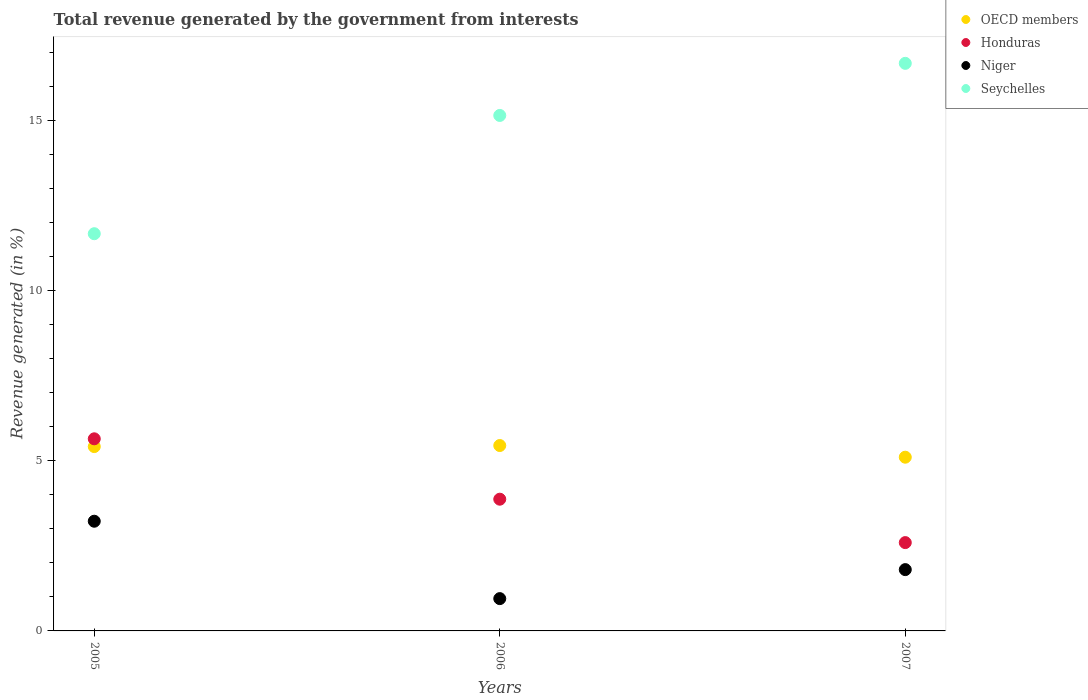How many different coloured dotlines are there?
Provide a succinct answer. 4. What is the total revenue generated in Honduras in 2007?
Offer a terse response. 2.6. Across all years, what is the maximum total revenue generated in Seychelles?
Make the answer very short. 16.68. Across all years, what is the minimum total revenue generated in Honduras?
Provide a succinct answer. 2.6. In which year was the total revenue generated in Niger maximum?
Your answer should be very brief. 2005. What is the total total revenue generated in OECD members in the graph?
Your response must be concise. 15.97. What is the difference between the total revenue generated in Honduras in 2005 and that in 2006?
Your answer should be compact. 1.77. What is the difference between the total revenue generated in OECD members in 2006 and the total revenue generated in Honduras in 2007?
Your response must be concise. 2.85. What is the average total revenue generated in Seychelles per year?
Offer a terse response. 14.5. In the year 2006, what is the difference between the total revenue generated in Honduras and total revenue generated in Niger?
Give a very brief answer. 2.92. What is the ratio of the total revenue generated in Niger in 2006 to that in 2007?
Provide a succinct answer. 0.53. Is the difference between the total revenue generated in Honduras in 2005 and 2007 greater than the difference between the total revenue generated in Niger in 2005 and 2007?
Provide a short and direct response. Yes. What is the difference between the highest and the second highest total revenue generated in OECD members?
Give a very brief answer. 0.03. What is the difference between the highest and the lowest total revenue generated in Seychelles?
Offer a terse response. 5.01. Is it the case that in every year, the sum of the total revenue generated in OECD members and total revenue generated in Seychelles  is greater than the sum of total revenue generated in Honduras and total revenue generated in Niger?
Your response must be concise. Yes. Is it the case that in every year, the sum of the total revenue generated in Niger and total revenue generated in Honduras  is greater than the total revenue generated in Seychelles?
Ensure brevity in your answer.  No. Is the total revenue generated in Honduras strictly greater than the total revenue generated in Seychelles over the years?
Offer a very short reply. No. How many years are there in the graph?
Your answer should be compact. 3. Are the values on the major ticks of Y-axis written in scientific E-notation?
Provide a succinct answer. No. Does the graph contain any zero values?
Provide a succinct answer. No. Where does the legend appear in the graph?
Offer a terse response. Top right. How many legend labels are there?
Offer a very short reply. 4. How are the legend labels stacked?
Your answer should be compact. Vertical. What is the title of the graph?
Your answer should be very brief. Total revenue generated by the government from interests. What is the label or title of the X-axis?
Offer a terse response. Years. What is the label or title of the Y-axis?
Offer a terse response. Revenue generated (in %). What is the Revenue generated (in %) in OECD members in 2005?
Give a very brief answer. 5.42. What is the Revenue generated (in %) of Honduras in 2005?
Provide a short and direct response. 5.64. What is the Revenue generated (in %) of Niger in 2005?
Your response must be concise. 3.22. What is the Revenue generated (in %) of Seychelles in 2005?
Your answer should be compact. 11.67. What is the Revenue generated (in %) in OECD members in 2006?
Your answer should be compact. 5.45. What is the Revenue generated (in %) in Honduras in 2006?
Give a very brief answer. 3.87. What is the Revenue generated (in %) in Niger in 2006?
Offer a terse response. 0.95. What is the Revenue generated (in %) in Seychelles in 2006?
Make the answer very short. 15.15. What is the Revenue generated (in %) of OECD members in 2007?
Offer a terse response. 5.1. What is the Revenue generated (in %) of Honduras in 2007?
Your answer should be very brief. 2.6. What is the Revenue generated (in %) of Niger in 2007?
Provide a short and direct response. 1.8. What is the Revenue generated (in %) in Seychelles in 2007?
Make the answer very short. 16.68. Across all years, what is the maximum Revenue generated (in %) in OECD members?
Make the answer very short. 5.45. Across all years, what is the maximum Revenue generated (in %) of Honduras?
Your response must be concise. 5.64. Across all years, what is the maximum Revenue generated (in %) of Niger?
Offer a very short reply. 3.22. Across all years, what is the maximum Revenue generated (in %) in Seychelles?
Keep it short and to the point. 16.68. Across all years, what is the minimum Revenue generated (in %) in OECD members?
Your answer should be compact. 5.1. Across all years, what is the minimum Revenue generated (in %) of Honduras?
Give a very brief answer. 2.6. Across all years, what is the minimum Revenue generated (in %) of Niger?
Your answer should be compact. 0.95. Across all years, what is the minimum Revenue generated (in %) of Seychelles?
Your answer should be very brief. 11.67. What is the total Revenue generated (in %) of OECD members in the graph?
Make the answer very short. 15.97. What is the total Revenue generated (in %) of Honduras in the graph?
Make the answer very short. 12.11. What is the total Revenue generated (in %) of Niger in the graph?
Offer a very short reply. 5.97. What is the total Revenue generated (in %) of Seychelles in the graph?
Offer a terse response. 43.49. What is the difference between the Revenue generated (in %) in OECD members in 2005 and that in 2006?
Your answer should be compact. -0.03. What is the difference between the Revenue generated (in %) in Honduras in 2005 and that in 2006?
Keep it short and to the point. 1.77. What is the difference between the Revenue generated (in %) of Niger in 2005 and that in 2006?
Give a very brief answer. 2.27. What is the difference between the Revenue generated (in %) of Seychelles in 2005 and that in 2006?
Make the answer very short. -3.47. What is the difference between the Revenue generated (in %) in OECD members in 2005 and that in 2007?
Ensure brevity in your answer.  0.31. What is the difference between the Revenue generated (in %) in Honduras in 2005 and that in 2007?
Your response must be concise. 3.05. What is the difference between the Revenue generated (in %) of Niger in 2005 and that in 2007?
Provide a succinct answer. 1.42. What is the difference between the Revenue generated (in %) of Seychelles in 2005 and that in 2007?
Keep it short and to the point. -5.01. What is the difference between the Revenue generated (in %) in OECD members in 2006 and that in 2007?
Your answer should be compact. 0.34. What is the difference between the Revenue generated (in %) in Honduras in 2006 and that in 2007?
Give a very brief answer. 1.28. What is the difference between the Revenue generated (in %) in Niger in 2006 and that in 2007?
Provide a succinct answer. -0.85. What is the difference between the Revenue generated (in %) in Seychelles in 2006 and that in 2007?
Your answer should be compact. -1.53. What is the difference between the Revenue generated (in %) of OECD members in 2005 and the Revenue generated (in %) of Honduras in 2006?
Make the answer very short. 1.55. What is the difference between the Revenue generated (in %) in OECD members in 2005 and the Revenue generated (in %) in Niger in 2006?
Your answer should be very brief. 4.47. What is the difference between the Revenue generated (in %) in OECD members in 2005 and the Revenue generated (in %) in Seychelles in 2006?
Provide a succinct answer. -9.73. What is the difference between the Revenue generated (in %) in Honduras in 2005 and the Revenue generated (in %) in Niger in 2006?
Provide a short and direct response. 4.7. What is the difference between the Revenue generated (in %) in Honduras in 2005 and the Revenue generated (in %) in Seychelles in 2006?
Your response must be concise. -9.5. What is the difference between the Revenue generated (in %) of Niger in 2005 and the Revenue generated (in %) of Seychelles in 2006?
Provide a short and direct response. -11.92. What is the difference between the Revenue generated (in %) in OECD members in 2005 and the Revenue generated (in %) in Honduras in 2007?
Offer a terse response. 2.82. What is the difference between the Revenue generated (in %) in OECD members in 2005 and the Revenue generated (in %) in Niger in 2007?
Your answer should be compact. 3.61. What is the difference between the Revenue generated (in %) of OECD members in 2005 and the Revenue generated (in %) of Seychelles in 2007?
Offer a terse response. -11.26. What is the difference between the Revenue generated (in %) in Honduras in 2005 and the Revenue generated (in %) in Niger in 2007?
Your response must be concise. 3.84. What is the difference between the Revenue generated (in %) of Honduras in 2005 and the Revenue generated (in %) of Seychelles in 2007?
Provide a short and direct response. -11.03. What is the difference between the Revenue generated (in %) in Niger in 2005 and the Revenue generated (in %) in Seychelles in 2007?
Keep it short and to the point. -13.45. What is the difference between the Revenue generated (in %) of OECD members in 2006 and the Revenue generated (in %) of Honduras in 2007?
Keep it short and to the point. 2.85. What is the difference between the Revenue generated (in %) in OECD members in 2006 and the Revenue generated (in %) in Niger in 2007?
Offer a terse response. 3.65. What is the difference between the Revenue generated (in %) of OECD members in 2006 and the Revenue generated (in %) of Seychelles in 2007?
Keep it short and to the point. -11.23. What is the difference between the Revenue generated (in %) of Honduras in 2006 and the Revenue generated (in %) of Niger in 2007?
Make the answer very short. 2.07. What is the difference between the Revenue generated (in %) in Honduras in 2006 and the Revenue generated (in %) in Seychelles in 2007?
Keep it short and to the point. -12.81. What is the difference between the Revenue generated (in %) in Niger in 2006 and the Revenue generated (in %) in Seychelles in 2007?
Provide a succinct answer. -15.73. What is the average Revenue generated (in %) of OECD members per year?
Make the answer very short. 5.32. What is the average Revenue generated (in %) in Honduras per year?
Provide a short and direct response. 4.04. What is the average Revenue generated (in %) of Niger per year?
Your response must be concise. 1.99. What is the average Revenue generated (in %) in Seychelles per year?
Your answer should be compact. 14.5. In the year 2005, what is the difference between the Revenue generated (in %) of OECD members and Revenue generated (in %) of Honduras?
Keep it short and to the point. -0.23. In the year 2005, what is the difference between the Revenue generated (in %) in OECD members and Revenue generated (in %) in Niger?
Offer a very short reply. 2.19. In the year 2005, what is the difference between the Revenue generated (in %) in OECD members and Revenue generated (in %) in Seychelles?
Your response must be concise. -6.25. In the year 2005, what is the difference between the Revenue generated (in %) of Honduras and Revenue generated (in %) of Niger?
Ensure brevity in your answer.  2.42. In the year 2005, what is the difference between the Revenue generated (in %) in Honduras and Revenue generated (in %) in Seychelles?
Your answer should be compact. -6.03. In the year 2005, what is the difference between the Revenue generated (in %) in Niger and Revenue generated (in %) in Seychelles?
Offer a terse response. -8.45. In the year 2006, what is the difference between the Revenue generated (in %) in OECD members and Revenue generated (in %) in Honduras?
Provide a succinct answer. 1.58. In the year 2006, what is the difference between the Revenue generated (in %) of OECD members and Revenue generated (in %) of Niger?
Offer a very short reply. 4.5. In the year 2006, what is the difference between the Revenue generated (in %) of OECD members and Revenue generated (in %) of Seychelles?
Your answer should be very brief. -9.7. In the year 2006, what is the difference between the Revenue generated (in %) of Honduras and Revenue generated (in %) of Niger?
Offer a very short reply. 2.92. In the year 2006, what is the difference between the Revenue generated (in %) in Honduras and Revenue generated (in %) in Seychelles?
Your answer should be compact. -11.28. In the year 2006, what is the difference between the Revenue generated (in %) of Niger and Revenue generated (in %) of Seychelles?
Offer a very short reply. -14.2. In the year 2007, what is the difference between the Revenue generated (in %) in OECD members and Revenue generated (in %) in Honduras?
Your answer should be compact. 2.51. In the year 2007, what is the difference between the Revenue generated (in %) of OECD members and Revenue generated (in %) of Niger?
Give a very brief answer. 3.3. In the year 2007, what is the difference between the Revenue generated (in %) in OECD members and Revenue generated (in %) in Seychelles?
Provide a short and direct response. -11.57. In the year 2007, what is the difference between the Revenue generated (in %) in Honduras and Revenue generated (in %) in Niger?
Provide a short and direct response. 0.79. In the year 2007, what is the difference between the Revenue generated (in %) of Honduras and Revenue generated (in %) of Seychelles?
Make the answer very short. -14.08. In the year 2007, what is the difference between the Revenue generated (in %) of Niger and Revenue generated (in %) of Seychelles?
Keep it short and to the point. -14.88. What is the ratio of the Revenue generated (in %) of Honduras in 2005 to that in 2006?
Make the answer very short. 1.46. What is the ratio of the Revenue generated (in %) in Niger in 2005 to that in 2006?
Provide a short and direct response. 3.4. What is the ratio of the Revenue generated (in %) of Seychelles in 2005 to that in 2006?
Your response must be concise. 0.77. What is the ratio of the Revenue generated (in %) of OECD members in 2005 to that in 2007?
Give a very brief answer. 1.06. What is the ratio of the Revenue generated (in %) of Honduras in 2005 to that in 2007?
Your answer should be very brief. 2.18. What is the ratio of the Revenue generated (in %) in Niger in 2005 to that in 2007?
Your answer should be compact. 1.79. What is the ratio of the Revenue generated (in %) of Seychelles in 2005 to that in 2007?
Your response must be concise. 0.7. What is the ratio of the Revenue generated (in %) of OECD members in 2006 to that in 2007?
Your response must be concise. 1.07. What is the ratio of the Revenue generated (in %) of Honduras in 2006 to that in 2007?
Offer a very short reply. 1.49. What is the ratio of the Revenue generated (in %) of Niger in 2006 to that in 2007?
Make the answer very short. 0.53. What is the ratio of the Revenue generated (in %) in Seychelles in 2006 to that in 2007?
Keep it short and to the point. 0.91. What is the difference between the highest and the second highest Revenue generated (in %) of OECD members?
Keep it short and to the point. 0.03. What is the difference between the highest and the second highest Revenue generated (in %) of Honduras?
Give a very brief answer. 1.77. What is the difference between the highest and the second highest Revenue generated (in %) of Niger?
Provide a short and direct response. 1.42. What is the difference between the highest and the second highest Revenue generated (in %) in Seychelles?
Keep it short and to the point. 1.53. What is the difference between the highest and the lowest Revenue generated (in %) of OECD members?
Your answer should be compact. 0.34. What is the difference between the highest and the lowest Revenue generated (in %) in Honduras?
Provide a succinct answer. 3.05. What is the difference between the highest and the lowest Revenue generated (in %) of Niger?
Give a very brief answer. 2.27. What is the difference between the highest and the lowest Revenue generated (in %) of Seychelles?
Give a very brief answer. 5.01. 